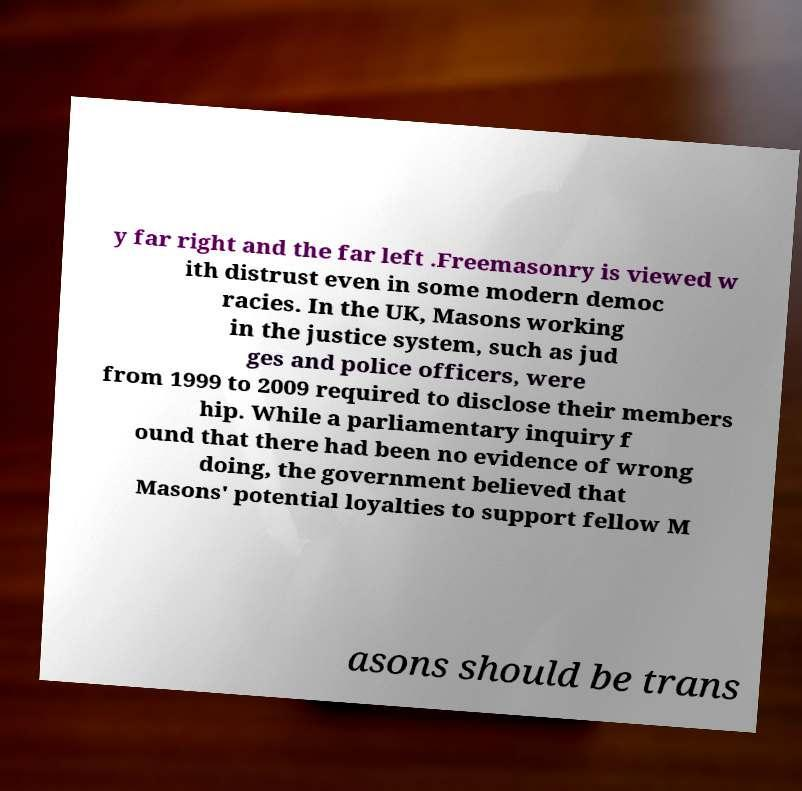For documentation purposes, I need the text within this image transcribed. Could you provide that? y far right and the far left .Freemasonry is viewed w ith distrust even in some modern democ racies. In the UK, Masons working in the justice system, such as jud ges and police officers, were from 1999 to 2009 required to disclose their members hip. While a parliamentary inquiry f ound that there had been no evidence of wrong doing, the government believed that Masons' potential loyalties to support fellow M asons should be trans 